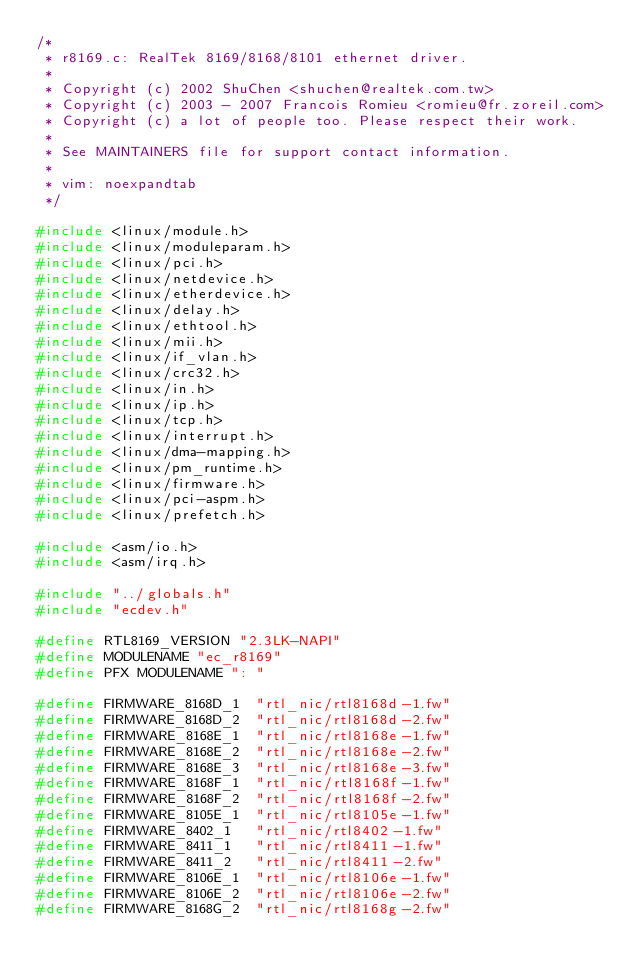Convert code to text. <code><loc_0><loc_0><loc_500><loc_500><_C_>/*
 * r8169.c: RealTek 8169/8168/8101 ethernet driver.
 *
 * Copyright (c) 2002 ShuChen <shuchen@realtek.com.tw>
 * Copyright (c) 2003 - 2007 Francois Romieu <romieu@fr.zoreil.com>
 * Copyright (c) a lot of people too. Please respect their work.
 *
 * See MAINTAINERS file for support contact information.
 *
 * vim: noexpandtab
 */

#include <linux/module.h>
#include <linux/moduleparam.h>
#include <linux/pci.h>
#include <linux/netdevice.h>
#include <linux/etherdevice.h>
#include <linux/delay.h>
#include <linux/ethtool.h>
#include <linux/mii.h>
#include <linux/if_vlan.h>
#include <linux/crc32.h>
#include <linux/in.h>
#include <linux/ip.h>
#include <linux/tcp.h>
#include <linux/interrupt.h>
#include <linux/dma-mapping.h>
#include <linux/pm_runtime.h>
#include <linux/firmware.h>
#include <linux/pci-aspm.h>
#include <linux/prefetch.h>

#include <asm/io.h>
#include <asm/irq.h>

#include "../globals.h"
#include "ecdev.h"

#define RTL8169_VERSION "2.3LK-NAPI"
#define MODULENAME "ec_r8169"
#define PFX MODULENAME ": "

#define FIRMWARE_8168D_1	"rtl_nic/rtl8168d-1.fw"
#define FIRMWARE_8168D_2	"rtl_nic/rtl8168d-2.fw"
#define FIRMWARE_8168E_1	"rtl_nic/rtl8168e-1.fw"
#define FIRMWARE_8168E_2	"rtl_nic/rtl8168e-2.fw"
#define FIRMWARE_8168E_3	"rtl_nic/rtl8168e-3.fw"
#define FIRMWARE_8168F_1	"rtl_nic/rtl8168f-1.fw"
#define FIRMWARE_8168F_2	"rtl_nic/rtl8168f-2.fw"
#define FIRMWARE_8105E_1	"rtl_nic/rtl8105e-1.fw"
#define FIRMWARE_8402_1		"rtl_nic/rtl8402-1.fw"
#define FIRMWARE_8411_1		"rtl_nic/rtl8411-1.fw"
#define FIRMWARE_8411_2		"rtl_nic/rtl8411-2.fw"
#define FIRMWARE_8106E_1	"rtl_nic/rtl8106e-1.fw"
#define FIRMWARE_8106E_2	"rtl_nic/rtl8106e-2.fw"
#define FIRMWARE_8168G_2	"rtl_nic/rtl8168g-2.fw"</code> 